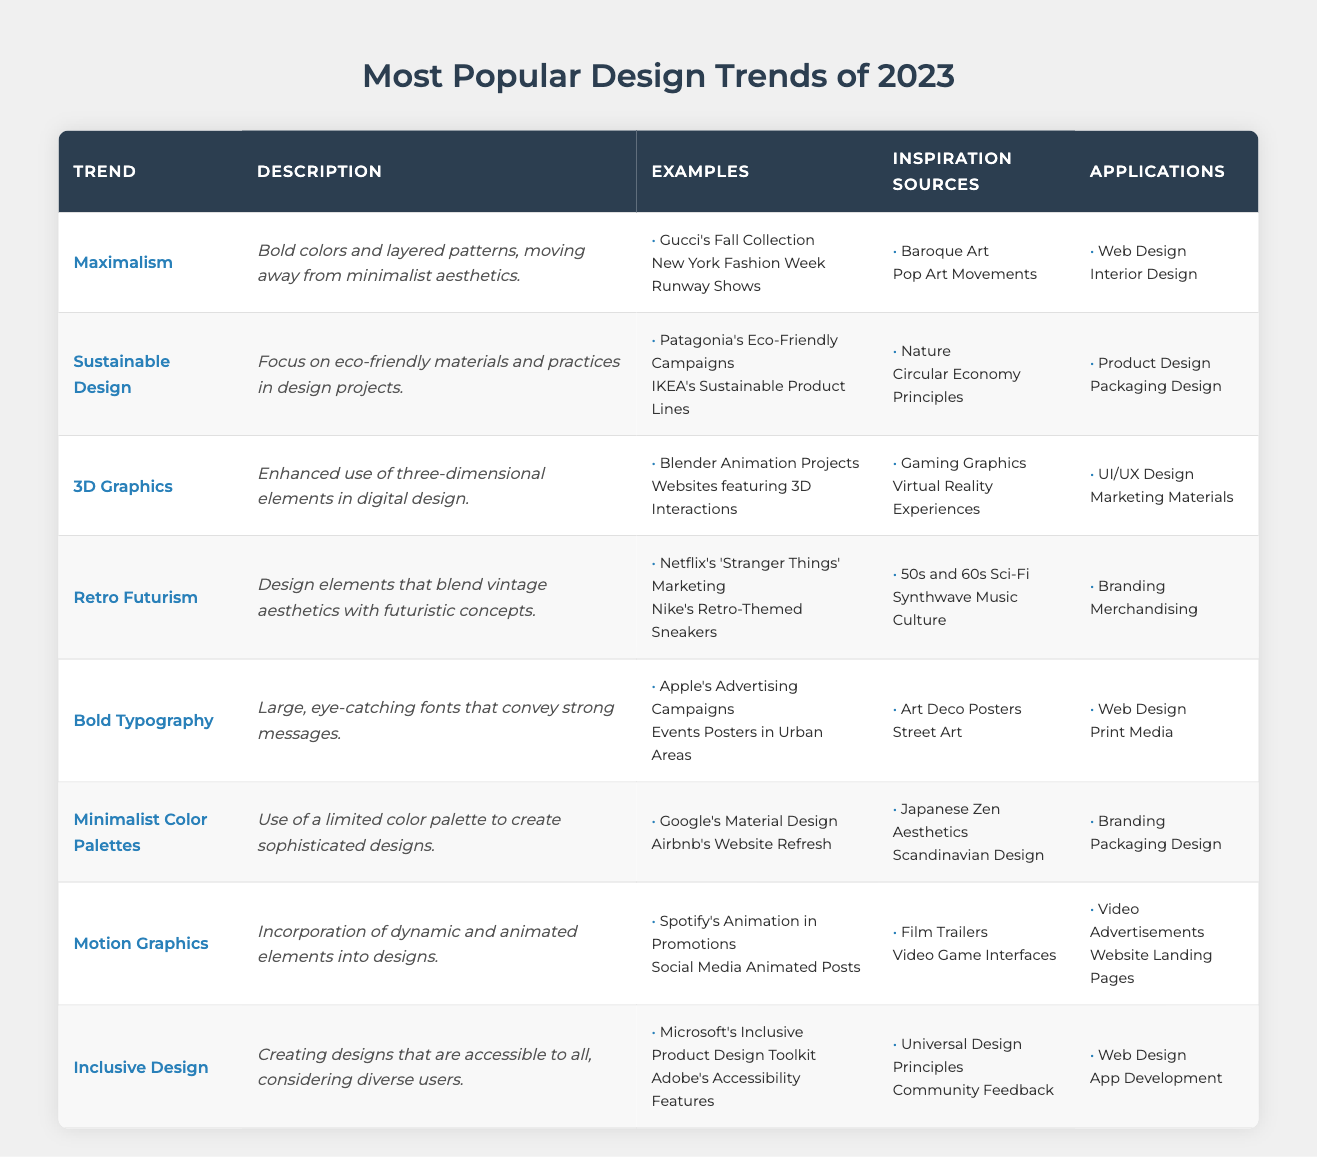What design trend focuses on eco-friendly materials? The table lists "Sustainable Design" as the trend that emphasizes eco-friendly materials and practices in design projects.
Answer: Sustainable Design Which trend uses large, eye-catching fonts? The trend that employs large, eye-catching fonts is "Bold Typography," as described in the table.
Answer: Bold Typography What are the applications of Maximalism? According to the table, Maximalism is applied in "Web Design" and "Interior Design."
Answer: Web Design, Interior Design Are any design trends inspired by nature? Yes, the "Sustainable Design" trend is inspired by nature, as noted in its inspiration sources.
Answer: Yes What two applications are associated with Motion Graphics? The table indicates that Motion Graphics are applied in "Video Advertisements" and "Website Landing Pages."
Answer: Video Advertisements, Website Landing Pages List all design trends that have branding as an application. The trends associated with branding are "Retro Futurism," "Bold Typography," "Minimalist Color Palettes," and "Inclusive Design," as shown in the applications column.
Answer: Retro Futurism, Bold Typography, Minimalist Color Palettes, Inclusive Design Which trend relates to accessibility? "Inclusive Design" is the trend related to accessibility, focusing on creating designs accessible to all users.
Answer: Inclusive Design How many trends can be applied to Web Design? The table indicates that four trends — "Maximalism," "3D Graphics," "Bold Typography," and "Motion Graphics" — can be applied to Web Design, making a total of four.
Answer: 4 What is the main description of Retro Futurism? The description of Retro Futurism explains that it includes design elements blending vintage aesthetics with futuristic concepts.
Answer: Design elements blending vintage and futuristic aesthetics Which trend has 'Gaming Graphics' as an inspiration source? The table lists "3D Graphics" as the trend that has Gaming Graphics as one of its inspiration sources.
Answer: 3D Graphics Are there any design trends that share the same inspiration source? Yes, "Minimalist Color Palettes" and "Sustainable Design" both share "Nature" as an inspiration source listed in the table.
Answer: Yes What should you consider when designing with Inclusive Design? When using Inclusive Design, one should consider diverse users and accessibility features, as highlighted in its description.
Answer: Diverse users and accessibility Which design trend appears in both Branding and Product Design applications? "Sustainable Design" is found in both Branding and Product Design applications, indicating its versatility in different design contexts.
Answer: Sustainable Design What is the overall theme of Bold Typography examples? The examples of Bold Typography emphasize distinctive advertising, particularly seen in Apple's campaigns and urban event posters, showcasing strong messaging.
Answer: Distinctive advertising and strong messaging 